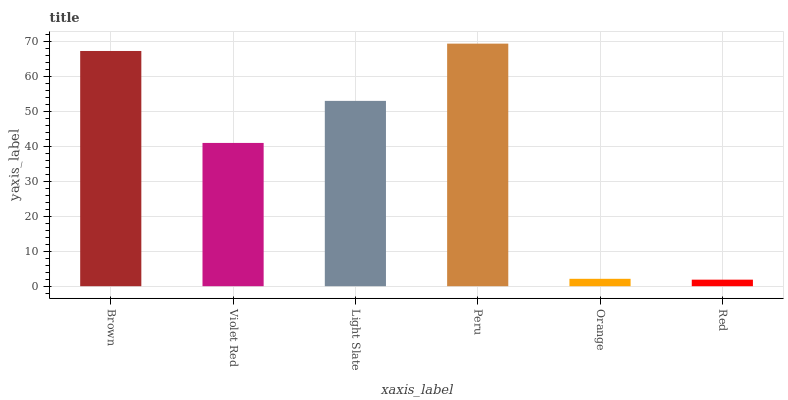Is Red the minimum?
Answer yes or no. Yes. Is Peru the maximum?
Answer yes or no. Yes. Is Violet Red the minimum?
Answer yes or no. No. Is Violet Red the maximum?
Answer yes or no. No. Is Brown greater than Violet Red?
Answer yes or no. Yes. Is Violet Red less than Brown?
Answer yes or no. Yes. Is Violet Red greater than Brown?
Answer yes or no. No. Is Brown less than Violet Red?
Answer yes or no. No. Is Light Slate the high median?
Answer yes or no. Yes. Is Violet Red the low median?
Answer yes or no. Yes. Is Violet Red the high median?
Answer yes or no. No. Is Orange the low median?
Answer yes or no. No. 